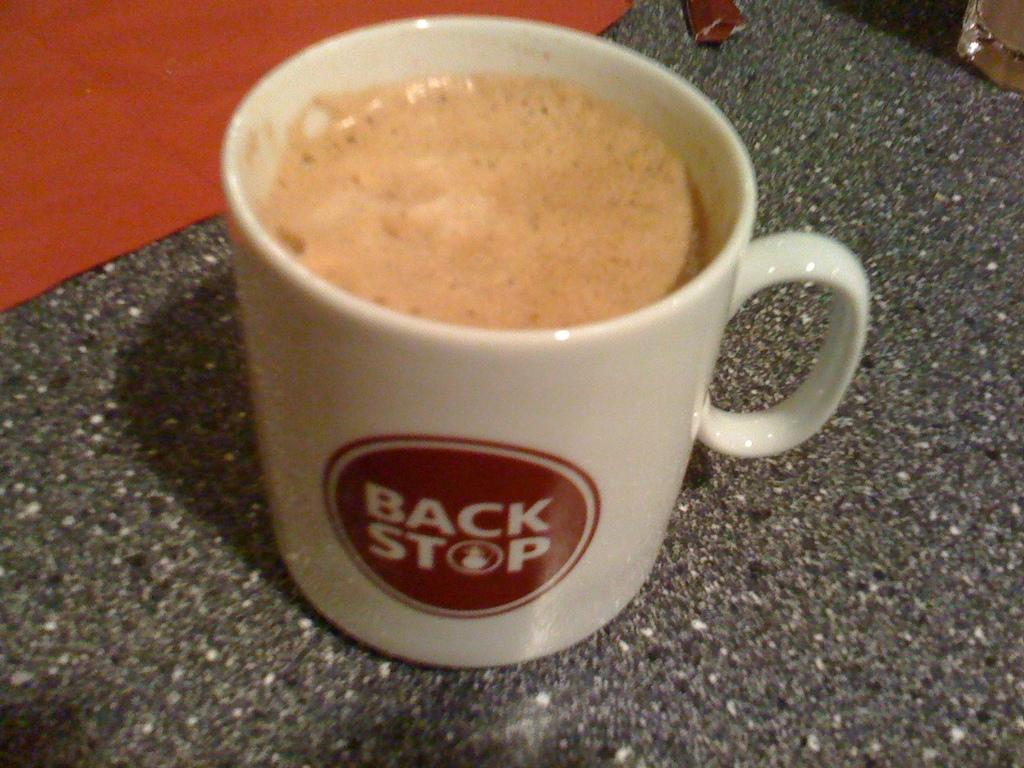What is the main object in the image? There is a coffee cup in the image. What is the surface beneath the coffee cup? The coffee cup is on a stone surface. Can you describe any other objects in the image? There is a cloth in the top left of the image. What type of apparatus is being used to brew the coffee in the image? There is no apparatus visible in the image, and the coffee cup is already filled with coffee. What type of silk material is draped over the coffee cup in the image? There is no silk material present in the image; the cloth mentioned is not specified as silk. 